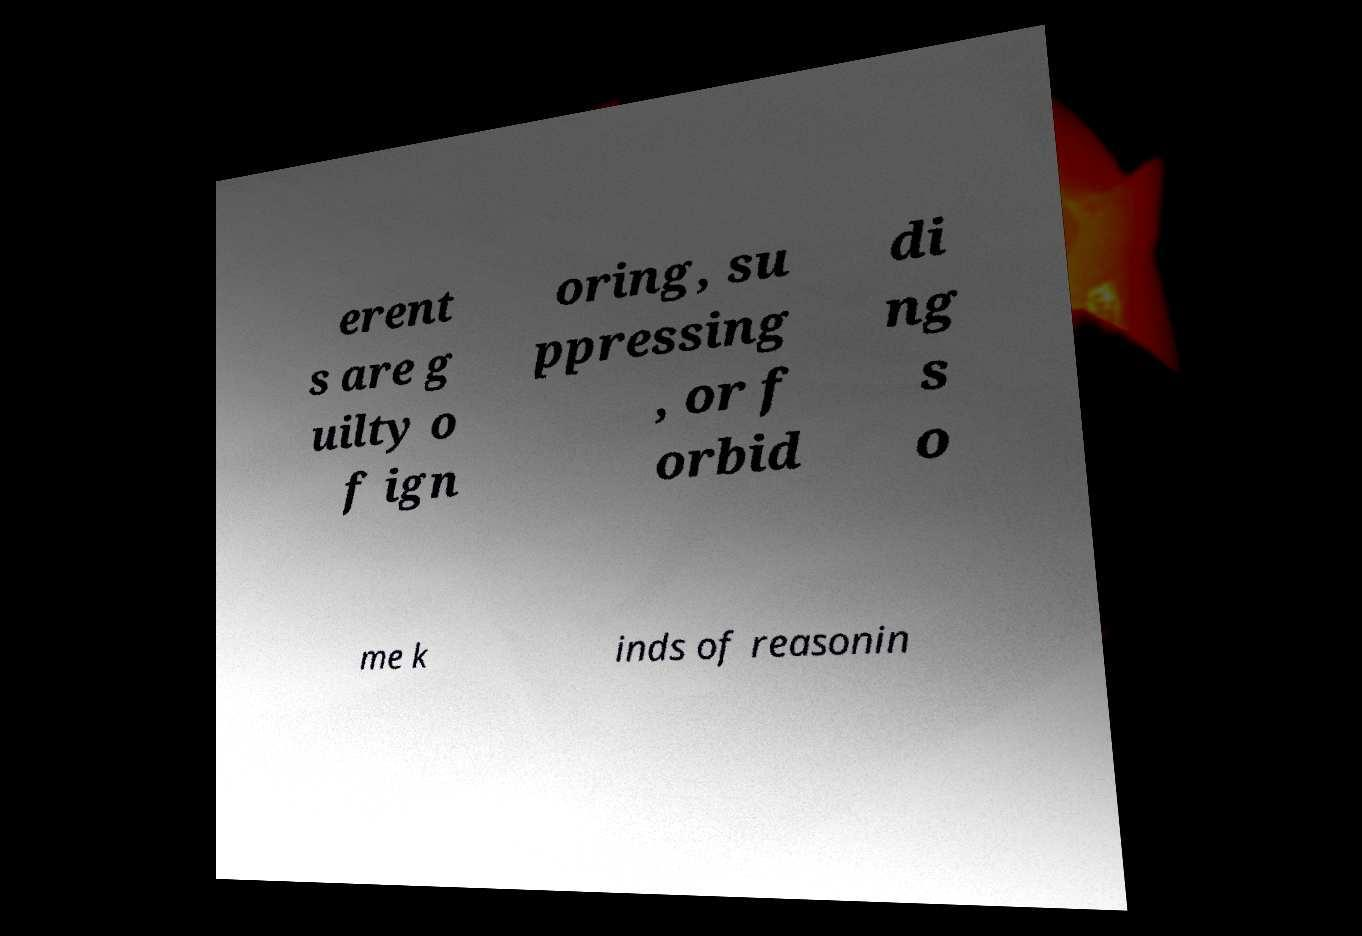What messages or text are displayed in this image? I need them in a readable, typed format. erent s are g uilty o f ign oring, su ppressing , or f orbid di ng s o me k inds of reasonin 